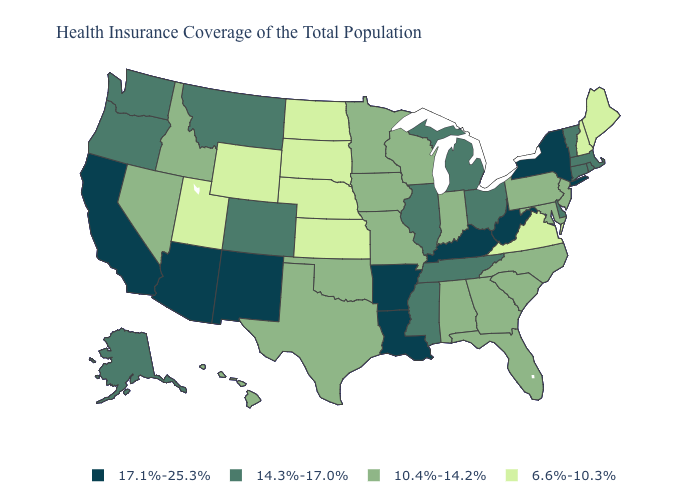Does Michigan have the lowest value in the USA?
Write a very short answer. No. What is the value of Arizona?
Keep it brief. 17.1%-25.3%. Among the states that border Washington , which have the lowest value?
Give a very brief answer. Idaho. Does Arkansas have the lowest value in the USA?
Answer briefly. No. Does Maryland have the lowest value in the South?
Be succinct. No. What is the value of Florida?
Answer briefly. 10.4%-14.2%. Name the states that have a value in the range 17.1%-25.3%?
Keep it brief. Arizona, Arkansas, California, Kentucky, Louisiana, New Mexico, New York, West Virginia. Is the legend a continuous bar?
Short answer required. No. What is the highest value in the USA?
Short answer required. 17.1%-25.3%. Does Minnesota have the lowest value in the USA?
Concise answer only. No. What is the value of Alaska?
Concise answer only. 14.3%-17.0%. Name the states that have a value in the range 10.4%-14.2%?
Give a very brief answer. Alabama, Florida, Georgia, Hawaii, Idaho, Indiana, Iowa, Maryland, Minnesota, Missouri, Nevada, New Jersey, North Carolina, Oklahoma, Pennsylvania, South Carolina, Texas, Wisconsin. Name the states that have a value in the range 17.1%-25.3%?
Be succinct. Arizona, Arkansas, California, Kentucky, Louisiana, New Mexico, New York, West Virginia. Does the first symbol in the legend represent the smallest category?
Keep it brief. No. What is the value of Montana?
Be succinct. 14.3%-17.0%. 